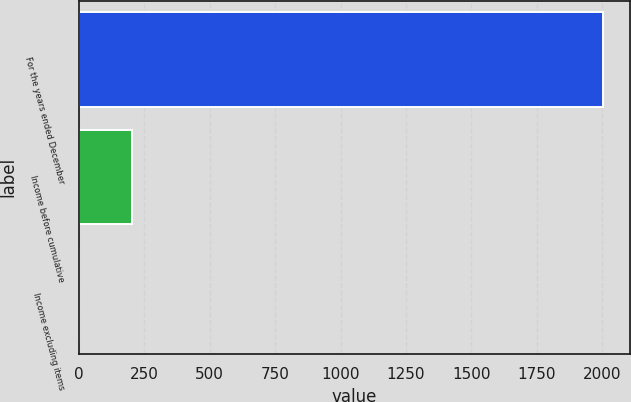Convert chart to OTSL. <chart><loc_0><loc_0><loc_500><loc_500><bar_chart><fcel>For the years ended December<fcel>Income before cumulative<fcel>Income excluding items<nl><fcel>2004<fcel>202.21<fcel>2.01<nl></chart> 